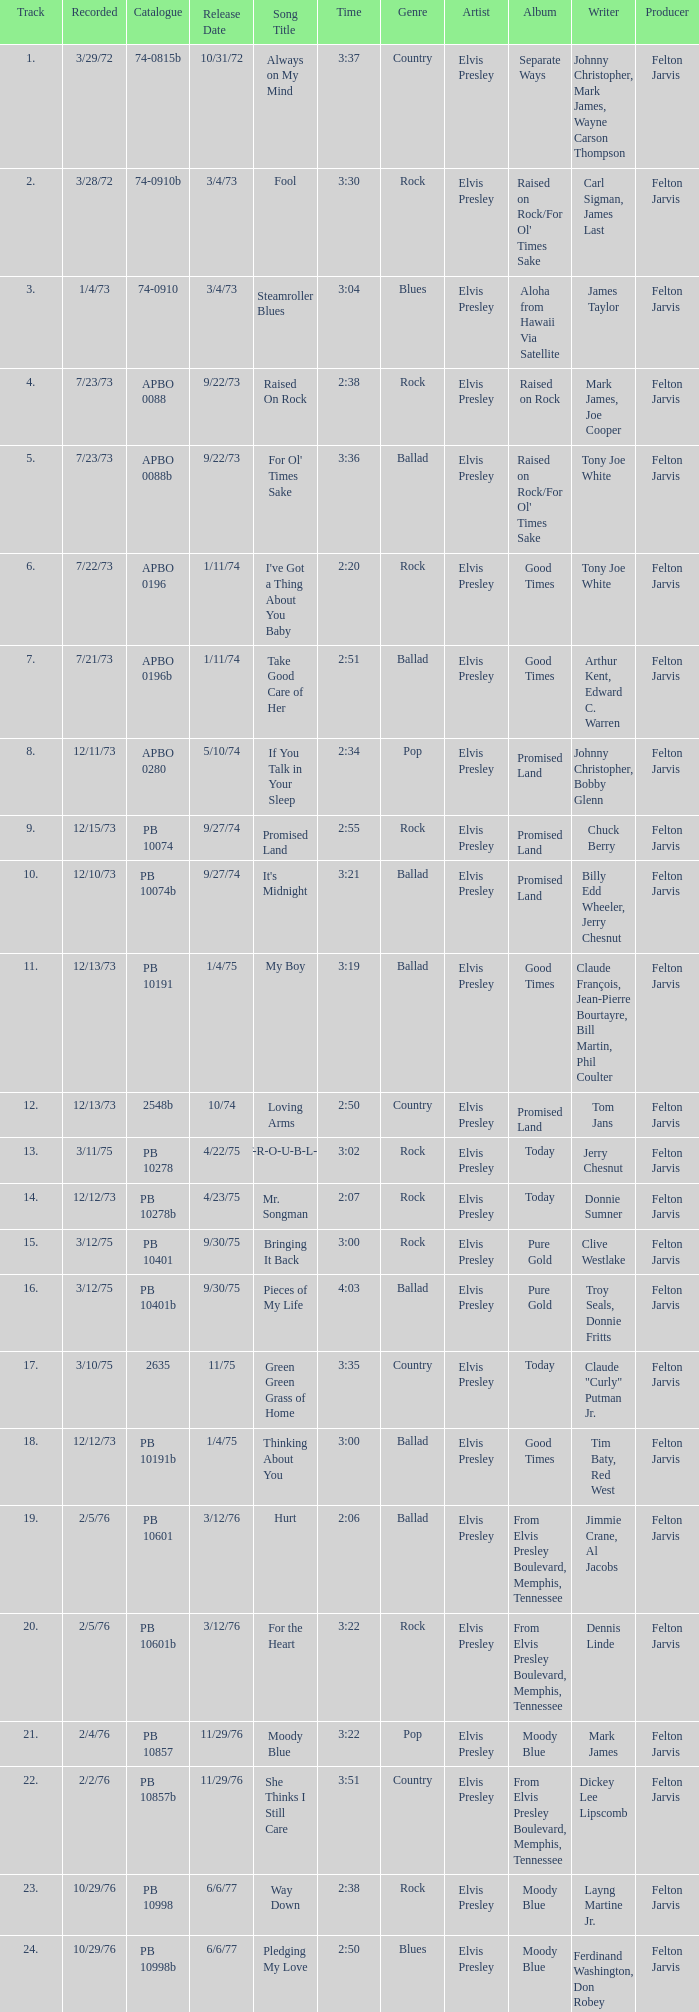I want the sum of tracks for raised on rock 4.0. 